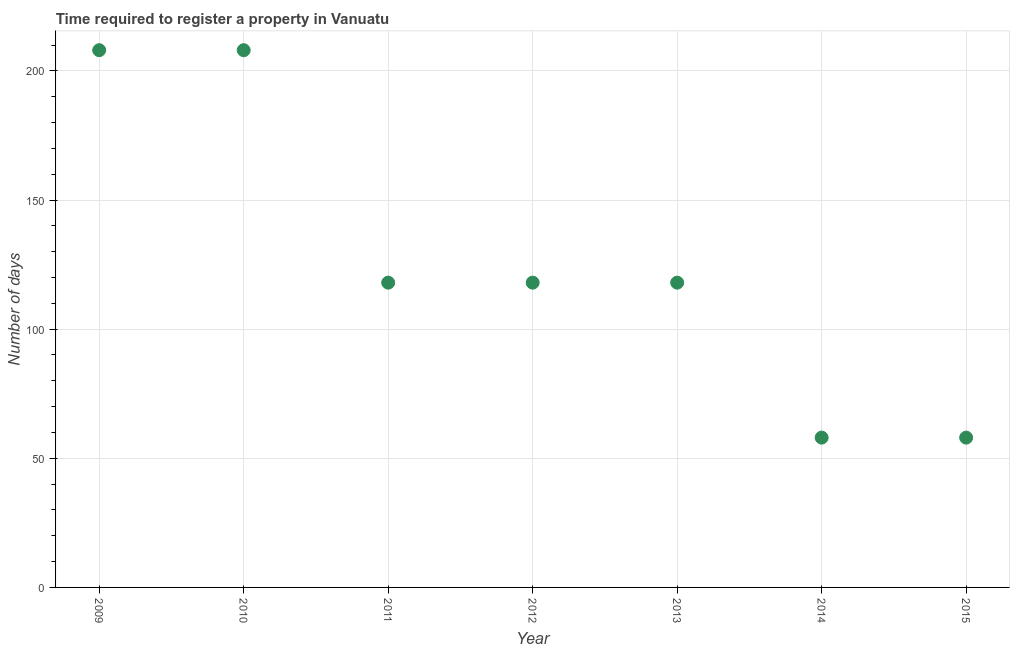What is the number of days required to register property in 2009?
Offer a terse response. 208. Across all years, what is the maximum number of days required to register property?
Offer a terse response. 208. Across all years, what is the minimum number of days required to register property?
Provide a short and direct response. 58. In which year was the number of days required to register property minimum?
Make the answer very short. 2014. What is the sum of the number of days required to register property?
Provide a succinct answer. 886. What is the difference between the number of days required to register property in 2013 and 2014?
Your answer should be compact. 60. What is the average number of days required to register property per year?
Keep it short and to the point. 126.57. What is the median number of days required to register property?
Your answer should be very brief. 118. Do a majority of the years between 2009 and 2013 (inclusive) have number of days required to register property greater than 70 days?
Ensure brevity in your answer.  Yes. What is the ratio of the number of days required to register property in 2010 to that in 2015?
Offer a very short reply. 3.59. Is the number of days required to register property in 2009 less than that in 2014?
Your answer should be very brief. No. What is the difference between the highest and the second highest number of days required to register property?
Make the answer very short. 0. Is the sum of the number of days required to register property in 2013 and 2014 greater than the maximum number of days required to register property across all years?
Provide a succinct answer. No. What is the difference between the highest and the lowest number of days required to register property?
Ensure brevity in your answer.  150. In how many years, is the number of days required to register property greater than the average number of days required to register property taken over all years?
Make the answer very short. 2. Does the number of days required to register property monotonically increase over the years?
Provide a short and direct response. No. How many dotlines are there?
Offer a very short reply. 1. Are the values on the major ticks of Y-axis written in scientific E-notation?
Your response must be concise. No. What is the title of the graph?
Your response must be concise. Time required to register a property in Vanuatu. What is the label or title of the X-axis?
Make the answer very short. Year. What is the label or title of the Y-axis?
Offer a terse response. Number of days. What is the Number of days in 2009?
Give a very brief answer. 208. What is the Number of days in 2010?
Provide a short and direct response. 208. What is the Number of days in 2011?
Your response must be concise. 118. What is the Number of days in 2012?
Your answer should be compact. 118. What is the Number of days in 2013?
Your response must be concise. 118. What is the difference between the Number of days in 2009 and 2010?
Offer a very short reply. 0. What is the difference between the Number of days in 2009 and 2011?
Your answer should be compact. 90. What is the difference between the Number of days in 2009 and 2014?
Offer a terse response. 150. What is the difference between the Number of days in 2009 and 2015?
Your response must be concise. 150. What is the difference between the Number of days in 2010 and 2011?
Ensure brevity in your answer.  90. What is the difference between the Number of days in 2010 and 2014?
Ensure brevity in your answer.  150. What is the difference between the Number of days in 2010 and 2015?
Your answer should be very brief. 150. What is the difference between the Number of days in 2011 and 2012?
Offer a terse response. 0. What is the difference between the Number of days in 2011 and 2013?
Offer a terse response. 0. What is the difference between the Number of days in 2011 and 2014?
Your answer should be compact. 60. What is the difference between the Number of days in 2011 and 2015?
Offer a terse response. 60. What is the difference between the Number of days in 2012 and 2013?
Keep it short and to the point. 0. What is the difference between the Number of days in 2012 and 2014?
Your response must be concise. 60. What is the difference between the Number of days in 2013 and 2015?
Ensure brevity in your answer.  60. What is the ratio of the Number of days in 2009 to that in 2010?
Give a very brief answer. 1. What is the ratio of the Number of days in 2009 to that in 2011?
Your answer should be compact. 1.76. What is the ratio of the Number of days in 2009 to that in 2012?
Make the answer very short. 1.76. What is the ratio of the Number of days in 2009 to that in 2013?
Ensure brevity in your answer.  1.76. What is the ratio of the Number of days in 2009 to that in 2014?
Provide a short and direct response. 3.59. What is the ratio of the Number of days in 2009 to that in 2015?
Provide a short and direct response. 3.59. What is the ratio of the Number of days in 2010 to that in 2011?
Provide a succinct answer. 1.76. What is the ratio of the Number of days in 2010 to that in 2012?
Ensure brevity in your answer.  1.76. What is the ratio of the Number of days in 2010 to that in 2013?
Keep it short and to the point. 1.76. What is the ratio of the Number of days in 2010 to that in 2014?
Give a very brief answer. 3.59. What is the ratio of the Number of days in 2010 to that in 2015?
Provide a succinct answer. 3.59. What is the ratio of the Number of days in 2011 to that in 2012?
Ensure brevity in your answer.  1. What is the ratio of the Number of days in 2011 to that in 2014?
Your answer should be compact. 2.03. What is the ratio of the Number of days in 2011 to that in 2015?
Ensure brevity in your answer.  2.03. What is the ratio of the Number of days in 2012 to that in 2013?
Offer a very short reply. 1. What is the ratio of the Number of days in 2012 to that in 2014?
Provide a succinct answer. 2.03. What is the ratio of the Number of days in 2012 to that in 2015?
Offer a terse response. 2.03. What is the ratio of the Number of days in 2013 to that in 2014?
Provide a succinct answer. 2.03. What is the ratio of the Number of days in 2013 to that in 2015?
Keep it short and to the point. 2.03. 